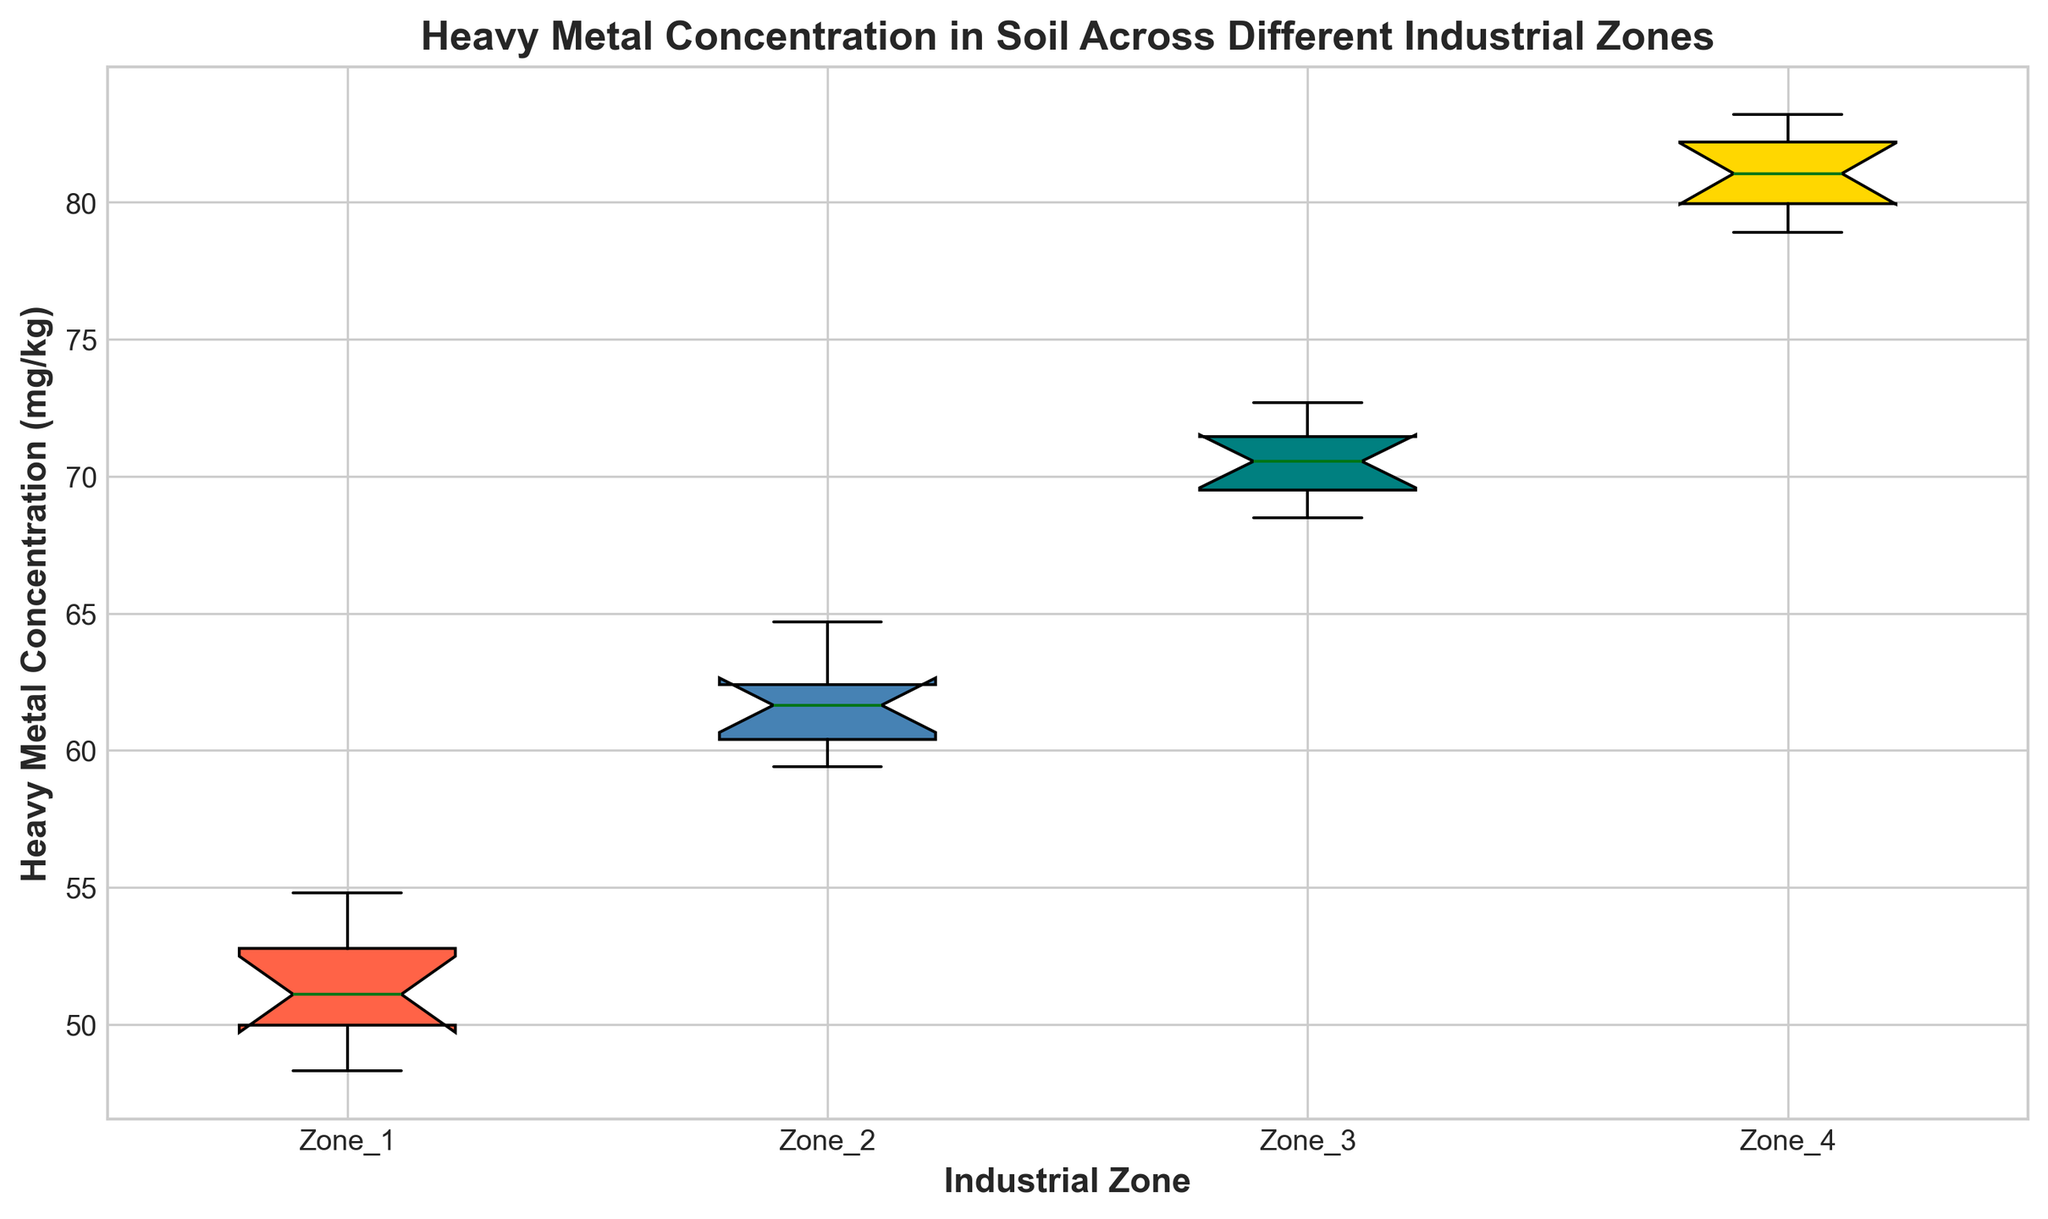Which industrial zone has the highest median heavy metal concentration? Find the median point in each box plot, visually represented by the line inside the box. Zone 4 has the highest median value compared to the other zones.
Answer: Zone 4 How does the range of heavy metal concentration in Zone 4 compare to Zone 1? Note the difference between the top and bottom whiskers of each box plot. Zone 4 has a larger range (spread) of values than Zone 1.
Answer: Zone 4 has a larger range Which industrial zone exhibits the lowest variability in heavy metal concentration? Variability in a box plot can be inferred from the interquartile range (IQR), which is the distance between the top and bottom of the box. Zone 1 has the shortest box, indicating the lowest variability.
Answer: Zone 1 What is the interquartile range (IQR) of heavy metal concentration in Zone 3? To find the IQR, subtract the value at the 25th percentile (bottom of the box) from the value at the 75th percentile (top of the box). The visual box height in Zone 3 indicates this range.
Answer: Approximately 2.7 (72.2 - 69.5) Which zone has the most outliers, and how are they visually indicated? Outliers are typically represented by individual points outside the whiskers of the box plot. Identify the zone with the most such points. Zone 3 appears to have points beyond the whiskers.
Answer: Zone 3 What is the median heavy metal concentration in Zone 2, and how does it compare to that in Zone 1? The median is represented by the central line in each box. Compare this line in Zone 2 and Zone 1. Zone 2 has a higher median concentration than Zone 1.
Answer: Zone 2 has a higher median than Zone 1 Which zone shows the greatest interquartile range (IQR), and what does this suggest about its data distribution? The box plot with the tallest box represents the greatest IQR. Identify that Zone and interpret the implication. Zone 4 has the largest IQR, indicating more variability in its data within the middle 50%.
Answer: Zone 4 Between Zone 2 and Zone 1, which has a wider spread of data, and how is this determined? Spread is observed by the total range of the whiskers. Zone 2 has a wider spread (longer whiskers) compared to Zone 1.
Answer: Zone 2 